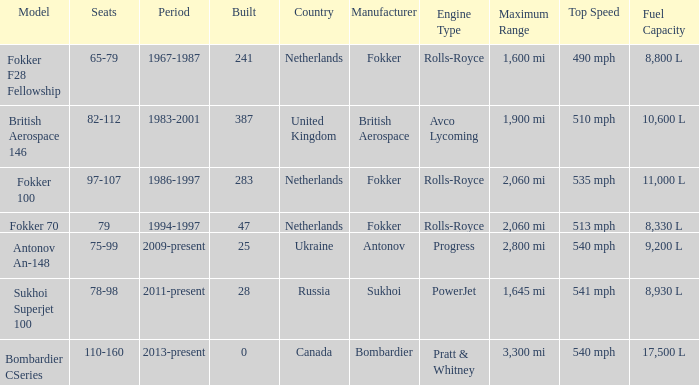Between which years were there 241 fokker 70 model cabins built? 1994-1997. 